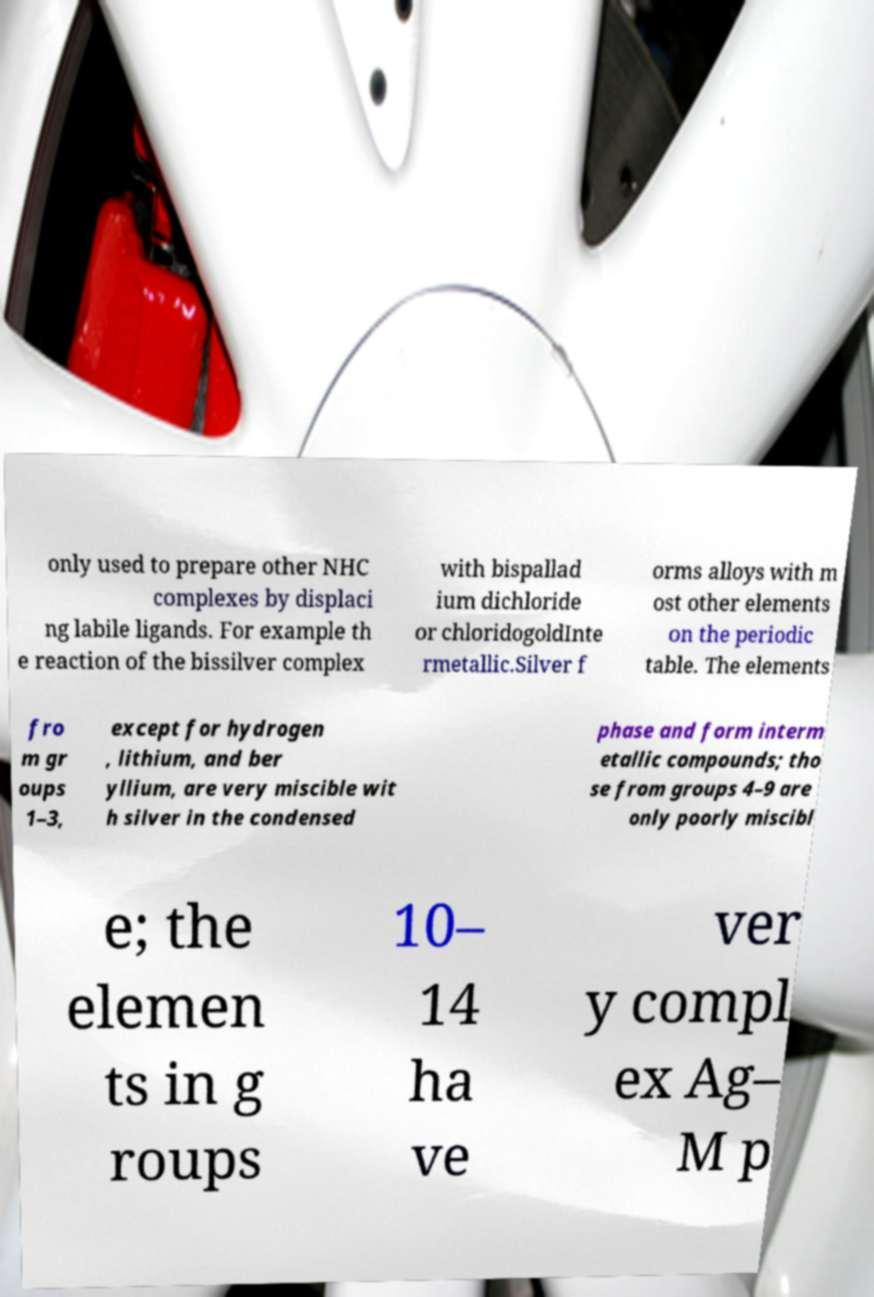Could you extract and type out the text from this image? only used to prepare other NHC complexes by displaci ng labile ligands. For example th e reaction of the bissilver complex with bispallad ium dichloride or chloridogoldInte rmetallic.Silver f orms alloys with m ost other elements on the periodic table. The elements fro m gr oups 1–3, except for hydrogen , lithium, and ber yllium, are very miscible wit h silver in the condensed phase and form interm etallic compounds; tho se from groups 4–9 are only poorly miscibl e; the elemen ts in g roups 10– 14 ha ve ver y compl ex Ag– M p 